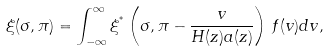Convert formula to latex. <formula><loc_0><loc_0><loc_500><loc_500>\xi ( \sigma , \pi ) = \int _ { - \infty } ^ { \infty } \xi ^ { ^ { * } } \left ( \sigma , \pi - \frac { v } { H ( z ) a ( z ) } \right ) \, f ( v ) d v ,</formula> 